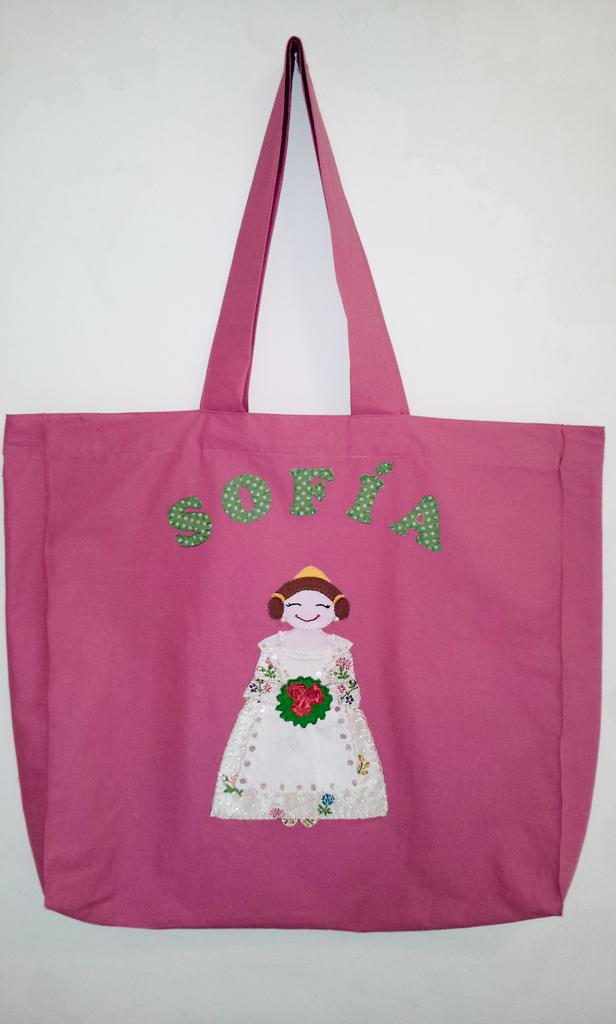What type of bag is visible in the image? There is a pink color cloth bag in the image. What is depicted on the bag? The bag has a painting on it. Who is present in the image? There is a woman in the image. What is the woman holding in her hand? The woman is holding flowers in her hand. Is the woman driving a car in the image? No, there is no car or driving activity depicted in the image. 